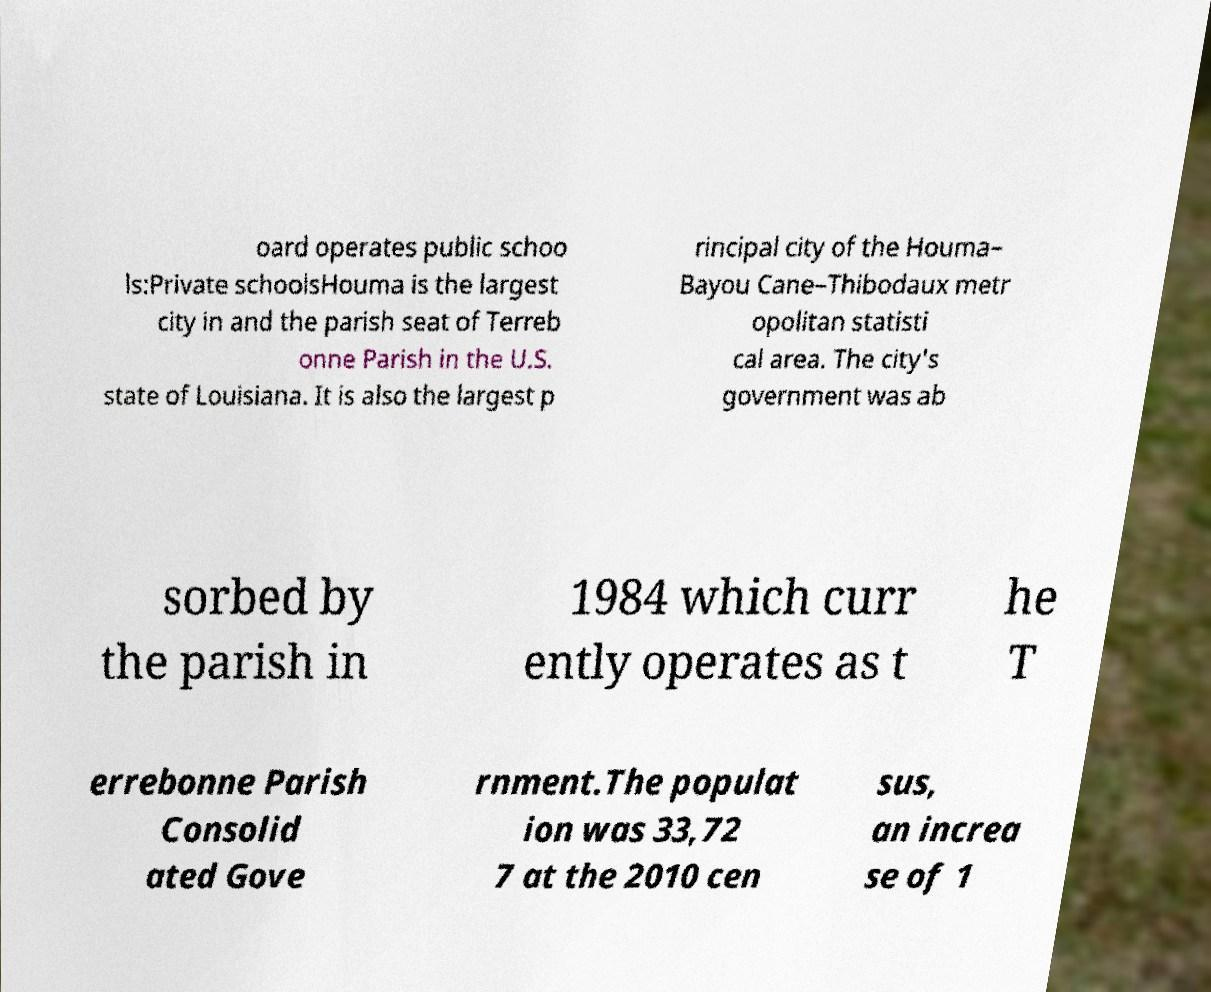For documentation purposes, I need the text within this image transcribed. Could you provide that? oard operates public schoo ls:Private schoolsHouma is the largest city in and the parish seat of Terreb onne Parish in the U.S. state of Louisiana. It is also the largest p rincipal city of the Houma– Bayou Cane–Thibodaux metr opolitan statisti cal area. The city's government was ab sorbed by the parish in 1984 which curr ently operates as t he T errebonne Parish Consolid ated Gove rnment.The populat ion was 33,72 7 at the 2010 cen sus, an increa se of 1 